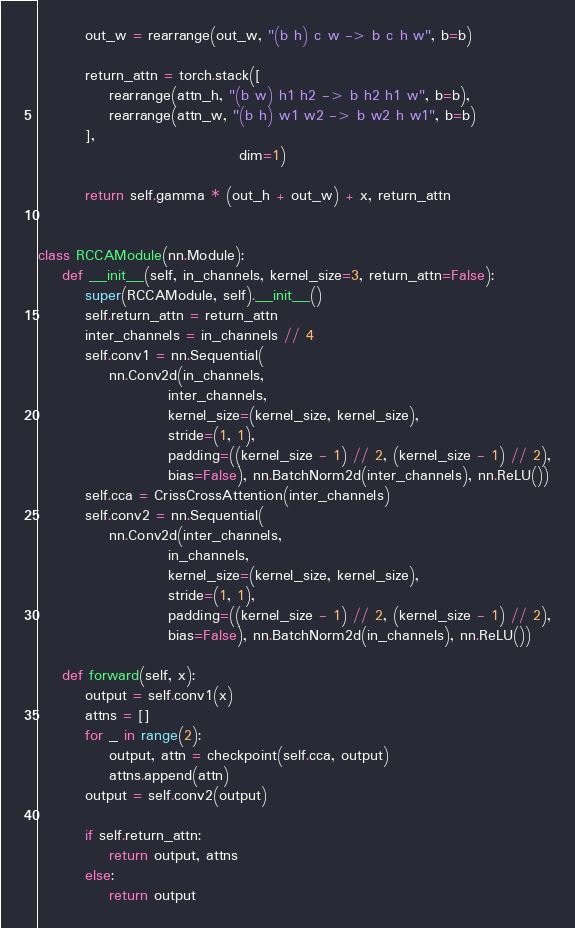<code> <loc_0><loc_0><loc_500><loc_500><_Python_>        out_w = rearrange(out_w, "(b h) c w -> b c h w", b=b)

        return_attn = torch.stack([
            rearrange(attn_h, "(b w) h1 h2 -> b h2 h1 w", b=b),
            rearrange(attn_w, "(b h) w1 w2 -> b w2 h w1", b=b)
        ],
                                  dim=1)

        return self.gamma * (out_h + out_w) + x, return_attn


class RCCAModule(nn.Module):
    def __init__(self, in_channels, kernel_size=3, return_attn=False):
        super(RCCAModule, self).__init__()
        self.return_attn = return_attn
        inter_channels = in_channels // 4
        self.conv1 = nn.Sequential(
            nn.Conv2d(in_channels,
                      inter_channels,
                      kernel_size=(kernel_size, kernel_size),
                      stride=(1, 1),
                      padding=((kernel_size - 1) // 2, (kernel_size - 1) // 2),
                      bias=False), nn.BatchNorm2d(inter_channels), nn.ReLU())
        self.cca = CrissCrossAttention(inter_channels)
        self.conv2 = nn.Sequential(
            nn.Conv2d(inter_channels,
                      in_channels,
                      kernel_size=(kernel_size, kernel_size),
                      stride=(1, 1),
                      padding=((kernel_size - 1) // 2, (kernel_size - 1) // 2),
                      bias=False), nn.BatchNorm2d(in_channels), nn.ReLU())

    def forward(self, x):
        output = self.conv1(x)
        attns = []
        for _ in range(2):
            output, attn = checkpoint(self.cca, output)
            attns.append(attn)
        output = self.conv2(output)

        if self.return_attn:
            return output, attns
        else:
            return output
</code> 